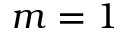<formula> <loc_0><loc_0><loc_500><loc_500>m = 1</formula> 